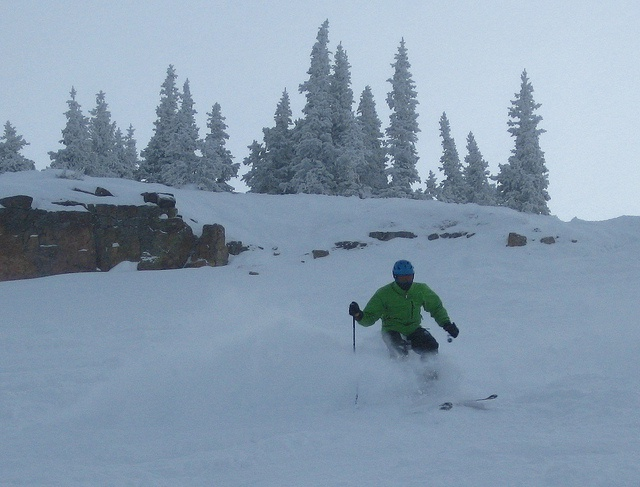Describe the objects in this image and their specific colors. I can see people in lightblue, darkgreen, black, teal, and gray tones and skis in lightblue, gray, and darkgray tones in this image. 